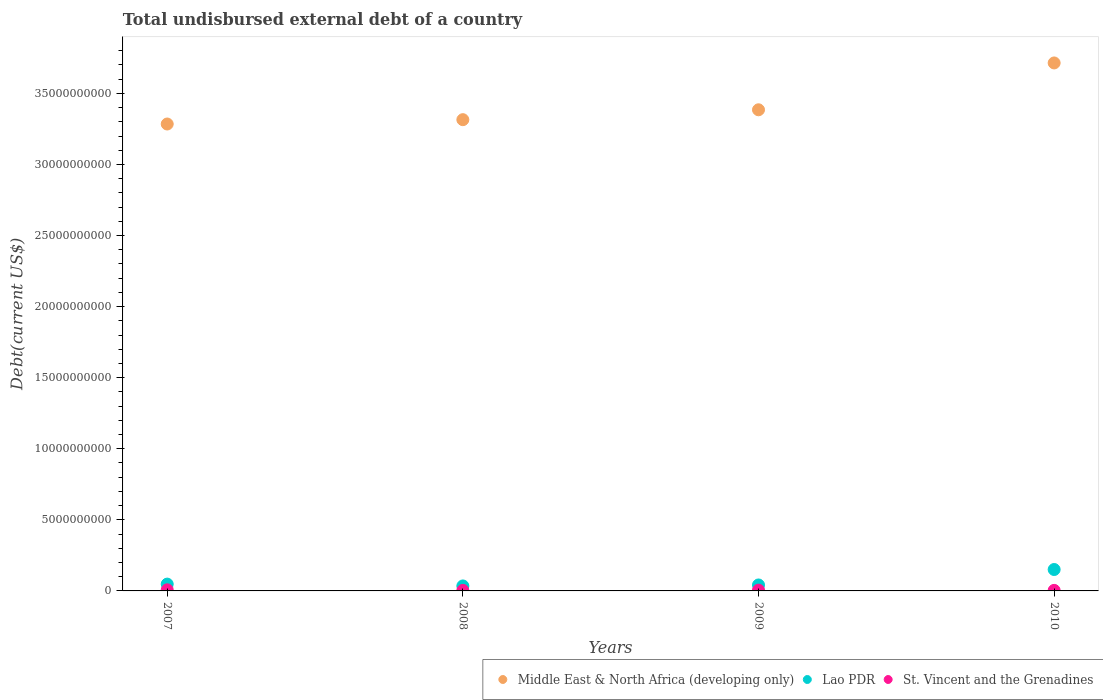What is the total undisbursed external debt in Lao PDR in 2010?
Keep it short and to the point. 1.51e+09. Across all years, what is the maximum total undisbursed external debt in St. Vincent and the Grenadines?
Keep it short and to the point. 7.76e+07. Across all years, what is the minimum total undisbursed external debt in St. Vincent and the Grenadines?
Your answer should be very brief. 3.71e+07. In which year was the total undisbursed external debt in Middle East & North Africa (developing only) maximum?
Make the answer very short. 2010. In which year was the total undisbursed external debt in Middle East & North Africa (developing only) minimum?
Your answer should be compact. 2007. What is the total total undisbursed external debt in Lao PDR in the graph?
Offer a very short reply. 2.76e+09. What is the difference between the total undisbursed external debt in Middle East & North Africa (developing only) in 2009 and that in 2010?
Offer a very short reply. -3.30e+09. What is the difference between the total undisbursed external debt in St. Vincent and the Grenadines in 2009 and the total undisbursed external debt in Middle East & North Africa (developing only) in 2007?
Make the answer very short. -3.28e+1. What is the average total undisbursed external debt in St. Vincent and the Grenadines per year?
Provide a short and direct response. 5.17e+07. In the year 2010, what is the difference between the total undisbursed external debt in Lao PDR and total undisbursed external debt in Middle East & North Africa (developing only)?
Provide a succinct answer. -3.56e+1. In how many years, is the total undisbursed external debt in Middle East & North Africa (developing only) greater than 25000000000 US$?
Provide a short and direct response. 4. What is the ratio of the total undisbursed external debt in St. Vincent and the Grenadines in 2007 to that in 2010?
Provide a short and direct response. 2.03. Is the total undisbursed external debt in St. Vincent and the Grenadines in 2008 less than that in 2010?
Give a very brief answer. Yes. What is the difference between the highest and the second highest total undisbursed external debt in St. Vincent and the Grenadines?
Your response must be concise. 2.36e+07. What is the difference between the highest and the lowest total undisbursed external debt in St. Vincent and the Grenadines?
Your answer should be compact. 4.05e+07. Is the sum of the total undisbursed external debt in Lao PDR in 2008 and 2010 greater than the maximum total undisbursed external debt in St. Vincent and the Grenadines across all years?
Provide a succinct answer. Yes. How many years are there in the graph?
Provide a short and direct response. 4. Does the graph contain grids?
Your response must be concise. No. Where does the legend appear in the graph?
Offer a terse response. Bottom right. What is the title of the graph?
Your answer should be very brief. Total undisbursed external debt of a country. Does "Small states" appear as one of the legend labels in the graph?
Offer a terse response. No. What is the label or title of the X-axis?
Make the answer very short. Years. What is the label or title of the Y-axis?
Your answer should be very brief. Debt(current US$). What is the Debt(current US$) of Middle East & North Africa (developing only) in 2007?
Give a very brief answer. 3.28e+1. What is the Debt(current US$) of Lao PDR in 2007?
Your answer should be very brief. 4.79e+08. What is the Debt(current US$) of St. Vincent and the Grenadines in 2007?
Your answer should be very brief. 7.76e+07. What is the Debt(current US$) of Middle East & North Africa (developing only) in 2008?
Offer a very short reply. 3.31e+1. What is the Debt(current US$) of Lao PDR in 2008?
Offer a very short reply. 3.50e+08. What is the Debt(current US$) in St. Vincent and the Grenadines in 2008?
Offer a very short reply. 3.71e+07. What is the Debt(current US$) in Middle East & North Africa (developing only) in 2009?
Your answer should be very brief. 3.38e+1. What is the Debt(current US$) in Lao PDR in 2009?
Your response must be concise. 4.19e+08. What is the Debt(current US$) in St. Vincent and the Grenadines in 2009?
Make the answer very short. 5.40e+07. What is the Debt(current US$) in Middle East & North Africa (developing only) in 2010?
Provide a succinct answer. 3.71e+1. What is the Debt(current US$) in Lao PDR in 2010?
Provide a succinct answer. 1.51e+09. What is the Debt(current US$) of St. Vincent and the Grenadines in 2010?
Make the answer very short. 3.82e+07. Across all years, what is the maximum Debt(current US$) of Middle East & North Africa (developing only)?
Your answer should be very brief. 3.71e+1. Across all years, what is the maximum Debt(current US$) of Lao PDR?
Make the answer very short. 1.51e+09. Across all years, what is the maximum Debt(current US$) of St. Vincent and the Grenadines?
Provide a succinct answer. 7.76e+07. Across all years, what is the minimum Debt(current US$) in Middle East & North Africa (developing only)?
Offer a very short reply. 3.28e+1. Across all years, what is the minimum Debt(current US$) in Lao PDR?
Provide a short and direct response. 3.50e+08. Across all years, what is the minimum Debt(current US$) of St. Vincent and the Grenadines?
Offer a terse response. 3.71e+07. What is the total Debt(current US$) in Middle East & North Africa (developing only) in the graph?
Your answer should be very brief. 1.37e+11. What is the total Debt(current US$) in Lao PDR in the graph?
Provide a short and direct response. 2.76e+09. What is the total Debt(current US$) in St. Vincent and the Grenadines in the graph?
Give a very brief answer. 2.07e+08. What is the difference between the Debt(current US$) of Middle East & North Africa (developing only) in 2007 and that in 2008?
Offer a very short reply. -3.05e+08. What is the difference between the Debt(current US$) in Lao PDR in 2007 and that in 2008?
Provide a short and direct response. 1.29e+08. What is the difference between the Debt(current US$) of St. Vincent and the Grenadines in 2007 and that in 2008?
Provide a succinct answer. 4.05e+07. What is the difference between the Debt(current US$) in Middle East & North Africa (developing only) in 2007 and that in 2009?
Offer a very short reply. -1.00e+09. What is the difference between the Debt(current US$) of Lao PDR in 2007 and that in 2009?
Your response must be concise. 5.98e+07. What is the difference between the Debt(current US$) in St. Vincent and the Grenadines in 2007 and that in 2009?
Make the answer very short. 2.36e+07. What is the difference between the Debt(current US$) of Middle East & North Africa (developing only) in 2007 and that in 2010?
Your response must be concise. -4.30e+09. What is the difference between the Debt(current US$) of Lao PDR in 2007 and that in 2010?
Ensure brevity in your answer.  -1.03e+09. What is the difference between the Debt(current US$) of St. Vincent and the Grenadines in 2007 and that in 2010?
Your answer should be compact. 3.93e+07. What is the difference between the Debt(current US$) in Middle East & North Africa (developing only) in 2008 and that in 2009?
Ensure brevity in your answer.  -6.95e+08. What is the difference between the Debt(current US$) of Lao PDR in 2008 and that in 2009?
Provide a short and direct response. -6.90e+07. What is the difference between the Debt(current US$) in St. Vincent and the Grenadines in 2008 and that in 2009?
Make the answer very short. -1.69e+07. What is the difference between the Debt(current US$) in Middle East & North Africa (developing only) in 2008 and that in 2010?
Your response must be concise. -3.99e+09. What is the difference between the Debt(current US$) of Lao PDR in 2008 and that in 2010?
Make the answer very short. -1.16e+09. What is the difference between the Debt(current US$) in St. Vincent and the Grenadines in 2008 and that in 2010?
Offer a very short reply. -1.17e+06. What is the difference between the Debt(current US$) of Middle East & North Africa (developing only) in 2009 and that in 2010?
Make the answer very short. -3.30e+09. What is the difference between the Debt(current US$) of Lao PDR in 2009 and that in 2010?
Your response must be concise. -1.09e+09. What is the difference between the Debt(current US$) in St. Vincent and the Grenadines in 2009 and that in 2010?
Offer a terse response. 1.57e+07. What is the difference between the Debt(current US$) in Middle East & North Africa (developing only) in 2007 and the Debt(current US$) in Lao PDR in 2008?
Your response must be concise. 3.25e+1. What is the difference between the Debt(current US$) of Middle East & North Africa (developing only) in 2007 and the Debt(current US$) of St. Vincent and the Grenadines in 2008?
Make the answer very short. 3.28e+1. What is the difference between the Debt(current US$) of Lao PDR in 2007 and the Debt(current US$) of St. Vincent and the Grenadines in 2008?
Offer a very short reply. 4.42e+08. What is the difference between the Debt(current US$) of Middle East & North Africa (developing only) in 2007 and the Debt(current US$) of Lao PDR in 2009?
Offer a very short reply. 3.24e+1. What is the difference between the Debt(current US$) of Middle East & North Africa (developing only) in 2007 and the Debt(current US$) of St. Vincent and the Grenadines in 2009?
Your answer should be very brief. 3.28e+1. What is the difference between the Debt(current US$) in Lao PDR in 2007 and the Debt(current US$) in St. Vincent and the Grenadines in 2009?
Your answer should be compact. 4.25e+08. What is the difference between the Debt(current US$) in Middle East & North Africa (developing only) in 2007 and the Debt(current US$) in Lao PDR in 2010?
Provide a succinct answer. 3.13e+1. What is the difference between the Debt(current US$) in Middle East & North Africa (developing only) in 2007 and the Debt(current US$) in St. Vincent and the Grenadines in 2010?
Provide a short and direct response. 3.28e+1. What is the difference between the Debt(current US$) in Lao PDR in 2007 and the Debt(current US$) in St. Vincent and the Grenadines in 2010?
Your answer should be compact. 4.41e+08. What is the difference between the Debt(current US$) of Middle East & North Africa (developing only) in 2008 and the Debt(current US$) of Lao PDR in 2009?
Keep it short and to the point. 3.27e+1. What is the difference between the Debt(current US$) in Middle East & North Africa (developing only) in 2008 and the Debt(current US$) in St. Vincent and the Grenadines in 2009?
Provide a succinct answer. 3.31e+1. What is the difference between the Debt(current US$) in Lao PDR in 2008 and the Debt(current US$) in St. Vincent and the Grenadines in 2009?
Your answer should be compact. 2.96e+08. What is the difference between the Debt(current US$) in Middle East & North Africa (developing only) in 2008 and the Debt(current US$) in Lao PDR in 2010?
Your response must be concise. 3.16e+1. What is the difference between the Debt(current US$) of Middle East & North Africa (developing only) in 2008 and the Debt(current US$) of St. Vincent and the Grenadines in 2010?
Offer a terse response. 3.31e+1. What is the difference between the Debt(current US$) in Lao PDR in 2008 and the Debt(current US$) in St. Vincent and the Grenadines in 2010?
Ensure brevity in your answer.  3.12e+08. What is the difference between the Debt(current US$) in Middle East & North Africa (developing only) in 2009 and the Debt(current US$) in Lao PDR in 2010?
Keep it short and to the point. 3.23e+1. What is the difference between the Debt(current US$) of Middle East & North Africa (developing only) in 2009 and the Debt(current US$) of St. Vincent and the Grenadines in 2010?
Keep it short and to the point. 3.38e+1. What is the difference between the Debt(current US$) in Lao PDR in 2009 and the Debt(current US$) in St. Vincent and the Grenadines in 2010?
Keep it short and to the point. 3.81e+08. What is the average Debt(current US$) of Middle East & North Africa (developing only) per year?
Your answer should be compact. 3.42e+1. What is the average Debt(current US$) in Lao PDR per year?
Make the answer very short. 6.89e+08. What is the average Debt(current US$) in St. Vincent and the Grenadines per year?
Give a very brief answer. 5.17e+07. In the year 2007, what is the difference between the Debt(current US$) in Middle East & North Africa (developing only) and Debt(current US$) in Lao PDR?
Offer a terse response. 3.24e+1. In the year 2007, what is the difference between the Debt(current US$) in Middle East & North Africa (developing only) and Debt(current US$) in St. Vincent and the Grenadines?
Provide a succinct answer. 3.28e+1. In the year 2007, what is the difference between the Debt(current US$) of Lao PDR and Debt(current US$) of St. Vincent and the Grenadines?
Make the answer very short. 4.02e+08. In the year 2008, what is the difference between the Debt(current US$) of Middle East & North Africa (developing only) and Debt(current US$) of Lao PDR?
Offer a terse response. 3.28e+1. In the year 2008, what is the difference between the Debt(current US$) of Middle East & North Africa (developing only) and Debt(current US$) of St. Vincent and the Grenadines?
Your answer should be compact. 3.31e+1. In the year 2008, what is the difference between the Debt(current US$) in Lao PDR and Debt(current US$) in St. Vincent and the Grenadines?
Give a very brief answer. 3.13e+08. In the year 2009, what is the difference between the Debt(current US$) of Middle East & North Africa (developing only) and Debt(current US$) of Lao PDR?
Provide a short and direct response. 3.34e+1. In the year 2009, what is the difference between the Debt(current US$) of Middle East & North Africa (developing only) and Debt(current US$) of St. Vincent and the Grenadines?
Keep it short and to the point. 3.38e+1. In the year 2009, what is the difference between the Debt(current US$) of Lao PDR and Debt(current US$) of St. Vincent and the Grenadines?
Offer a very short reply. 3.65e+08. In the year 2010, what is the difference between the Debt(current US$) in Middle East & North Africa (developing only) and Debt(current US$) in Lao PDR?
Offer a very short reply. 3.56e+1. In the year 2010, what is the difference between the Debt(current US$) of Middle East & North Africa (developing only) and Debt(current US$) of St. Vincent and the Grenadines?
Your answer should be compact. 3.71e+1. In the year 2010, what is the difference between the Debt(current US$) in Lao PDR and Debt(current US$) in St. Vincent and the Grenadines?
Ensure brevity in your answer.  1.47e+09. What is the ratio of the Debt(current US$) in Middle East & North Africa (developing only) in 2007 to that in 2008?
Make the answer very short. 0.99. What is the ratio of the Debt(current US$) in Lao PDR in 2007 to that in 2008?
Offer a very short reply. 1.37. What is the ratio of the Debt(current US$) in St. Vincent and the Grenadines in 2007 to that in 2008?
Ensure brevity in your answer.  2.09. What is the ratio of the Debt(current US$) of Middle East & North Africa (developing only) in 2007 to that in 2009?
Provide a short and direct response. 0.97. What is the ratio of the Debt(current US$) of Lao PDR in 2007 to that in 2009?
Your answer should be very brief. 1.14. What is the ratio of the Debt(current US$) of St. Vincent and the Grenadines in 2007 to that in 2009?
Offer a terse response. 1.44. What is the ratio of the Debt(current US$) of Middle East & North Africa (developing only) in 2007 to that in 2010?
Offer a very short reply. 0.88. What is the ratio of the Debt(current US$) of Lao PDR in 2007 to that in 2010?
Offer a terse response. 0.32. What is the ratio of the Debt(current US$) of St. Vincent and the Grenadines in 2007 to that in 2010?
Offer a very short reply. 2.03. What is the ratio of the Debt(current US$) in Middle East & North Africa (developing only) in 2008 to that in 2009?
Provide a succinct answer. 0.98. What is the ratio of the Debt(current US$) of Lao PDR in 2008 to that in 2009?
Keep it short and to the point. 0.84. What is the ratio of the Debt(current US$) in St. Vincent and the Grenadines in 2008 to that in 2009?
Your response must be concise. 0.69. What is the ratio of the Debt(current US$) of Middle East & North Africa (developing only) in 2008 to that in 2010?
Keep it short and to the point. 0.89. What is the ratio of the Debt(current US$) in Lao PDR in 2008 to that in 2010?
Your answer should be compact. 0.23. What is the ratio of the Debt(current US$) of St. Vincent and the Grenadines in 2008 to that in 2010?
Your answer should be compact. 0.97. What is the ratio of the Debt(current US$) of Middle East & North Africa (developing only) in 2009 to that in 2010?
Your answer should be compact. 0.91. What is the ratio of the Debt(current US$) of Lao PDR in 2009 to that in 2010?
Give a very brief answer. 0.28. What is the ratio of the Debt(current US$) in St. Vincent and the Grenadines in 2009 to that in 2010?
Your response must be concise. 1.41. What is the difference between the highest and the second highest Debt(current US$) of Middle East & North Africa (developing only)?
Keep it short and to the point. 3.30e+09. What is the difference between the highest and the second highest Debt(current US$) in Lao PDR?
Your answer should be very brief. 1.03e+09. What is the difference between the highest and the second highest Debt(current US$) of St. Vincent and the Grenadines?
Make the answer very short. 2.36e+07. What is the difference between the highest and the lowest Debt(current US$) of Middle East & North Africa (developing only)?
Your answer should be very brief. 4.30e+09. What is the difference between the highest and the lowest Debt(current US$) in Lao PDR?
Your response must be concise. 1.16e+09. What is the difference between the highest and the lowest Debt(current US$) of St. Vincent and the Grenadines?
Your answer should be compact. 4.05e+07. 